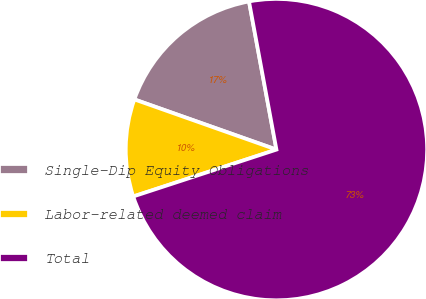<chart> <loc_0><loc_0><loc_500><loc_500><pie_chart><fcel>Single-Dip Equity Obligations<fcel>Labor-related deemed claim<fcel>Total<nl><fcel>16.68%<fcel>10.44%<fcel>72.88%<nl></chart> 